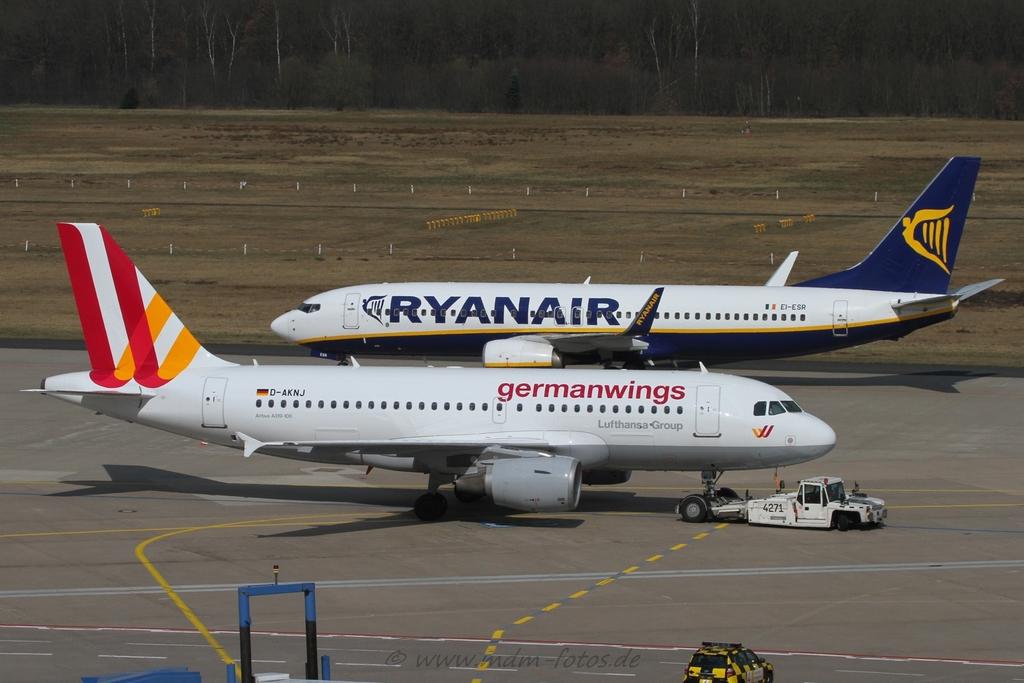What airline is the plane on the back?
Make the answer very short. Ryanair. What airline is the plane on the front?
Offer a very short reply. Germanwings. 